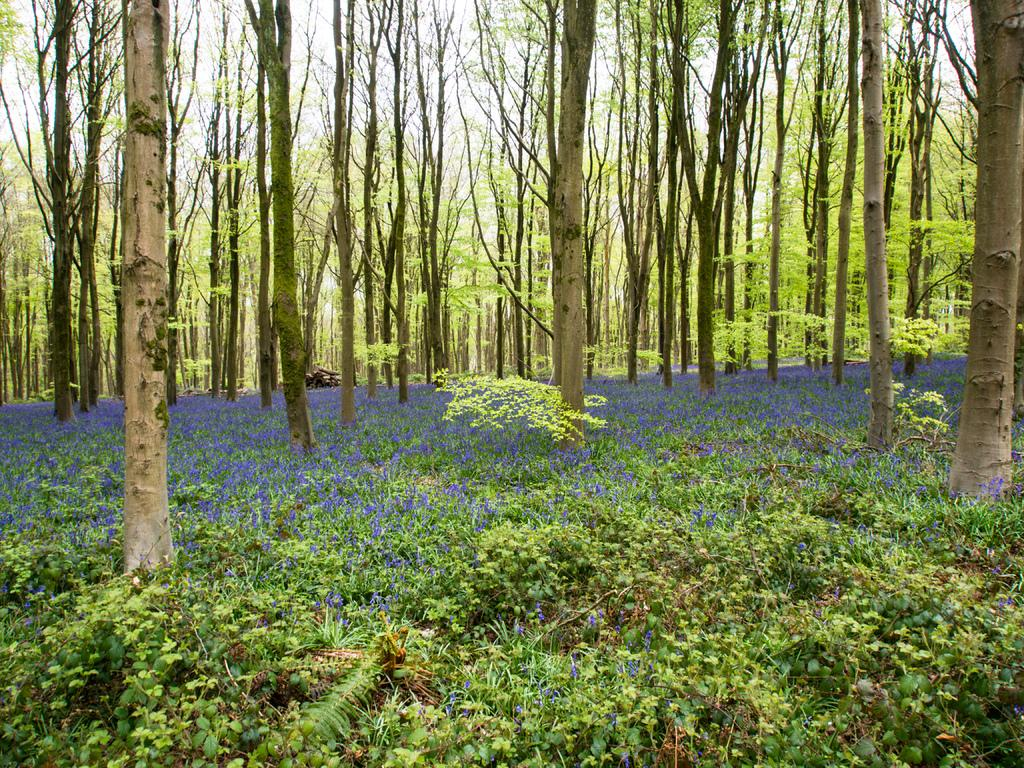What type of plants can be seen in the image? There are plants with flowers in the image. What other vegetation is present in the image? There are trees in the image. What can be seen in the background of the image? The sky is visible behind the trees in the image. What type of glue is being used to hold the flowers together in the image? There is no glue present in the image; the flowers are naturally attached to the plants. Can you tell me the name of the father of the person who took the picture? We do not have any information about the person who took the picture, so we cannot determine the name of their father. 